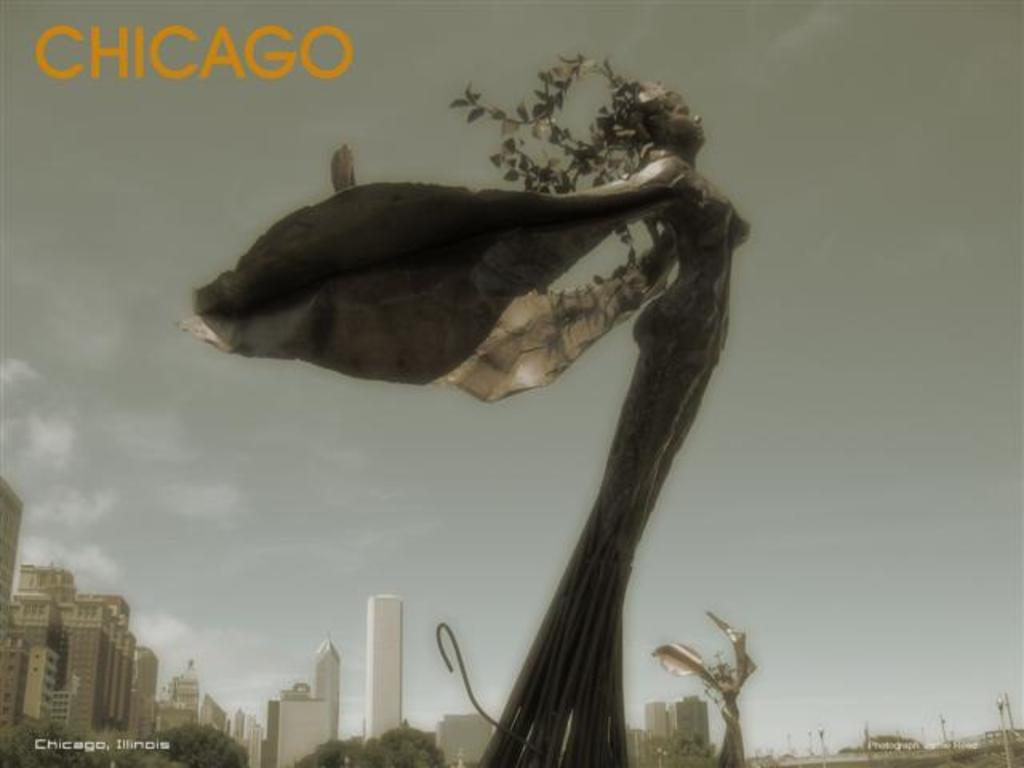What are the main subjects in the image? There are two giant sculptures in the image. What else can be seen in the image besides the sculptures? There are many buildings and trees in the image. Is there any text present in the image? Yes, there is some text in the top left corner of the image. What type of furniture can be seen in the image? There is no furniture present in the image. What is the name of the sculpture on the left side of the image? The provided facts do not include the names of the sculptures, so we cannot answer this question. 